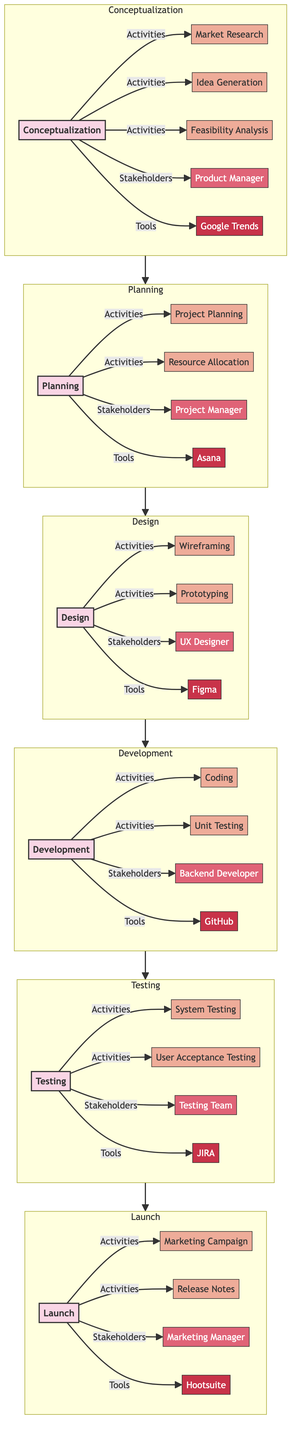What is the first phase in the diagram? The first phase listed in the diagram is "Conceptualization," which is prominent at the start of the clinical pathway.
Answer: Conceptualization How many key activities are in the Design phase? The Design phase includes three key activities: Wireframing, Prototyping, and User Experience (UX) Design, all of which are clearly articulated in that segment.
Answer: Three Who is the primary stakeholder in the Testing phase? The primary stakeholder identified in the Testing phase is the "Testing Team," as shown directly connected to that phase in the diagram.
Answer: Testing Team What tools are used during the Planning phase? During the Planning phase, the tools specified are Asana, Trello, and Microsoft Project, which are explicitly linked under that phase in the diagram.
Answer: Asana, Trello, Microsoft Project What follows the Development phase in the pathway? The next phase that follows the Development phase is the Testing phase, as represented by the flow direction in the diagram connecting these two.
Answer: Testing How many phases are there in total in this pathway? The diagram outlines a total of six phases, which can be counted sequentially from Conceptualization to Launch within the depicted flow.
Answer: Six Which tool is associated with the Launch phase? The tool identified with the Launch phase is Hootsuite, which is clearly displayed as part of the activities and tools in that specific phase.
Answer: Hootsuite What is the last key activity in the pathway? The last key activity listed in the pathway is "Post-Launch Support," which is part of the Launch phase and concludes the sequence of activities.
Answer: Post-Launch Support Who leads the Development phase? The stakeholders for the Development phase specifically include the Backend Developer, Frontend Developer, and Quality Assurance Engineer, making one of them, such as "Quality Assurance Engineer," a leading figure.
Answer: Quality Assurance Engineer 